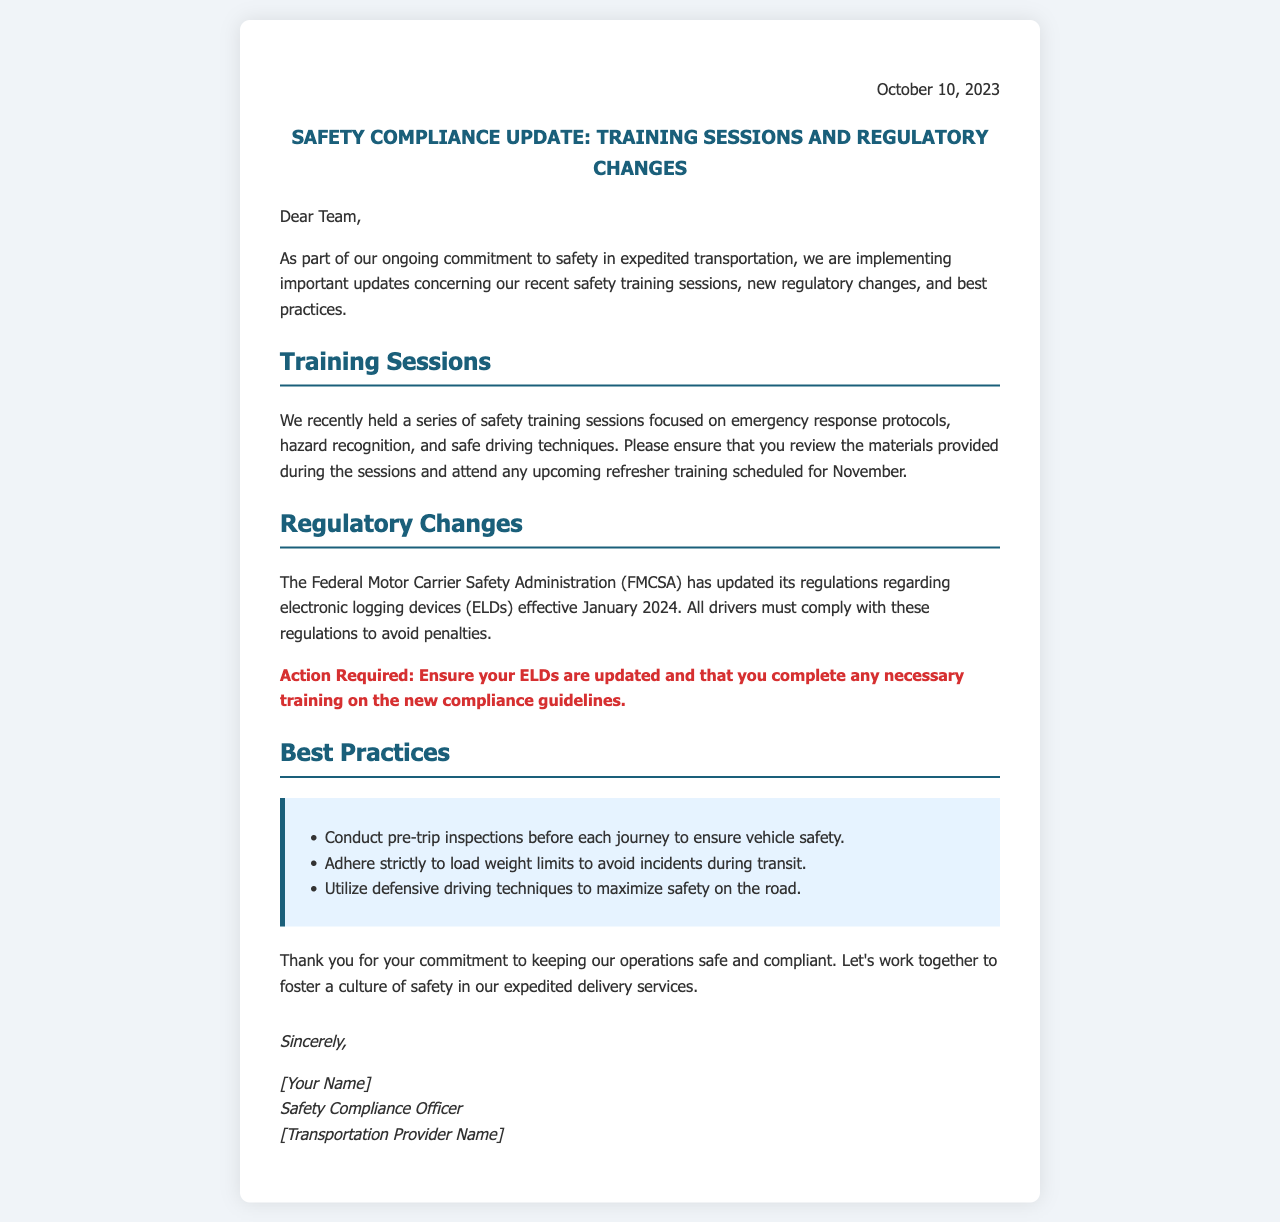What is the date of the letter? The date of the letter is mentioned at the start, indicating when it was written.
Answer: October 10, 2023 What is the main subject of the letter? The subject line provides a clear indication of what the letter generally addresses.
Answer: Safety Compliance Update: Training Sessions and Regulatory Changes What organization has updated its regulations? The document refers to the regulatory body responsible for the new rules concerning transport safety.
Answer: Federal Motor Carrier Safety Administration (FMCSA) When will drivers need to comply with the new electronic logging device regulations? The letter states when the new regulations will take effect, which is important for compliance planning.
Answer: January 2024 What is required of drivers regarding ELDs? Action required from the drivers is specified in a separate section of the letter.
Answer: Ensure your ELDs are updated What is one of the topics covered in the recent safety training sessions? The letter lists several topics that were included in the recent training sessions.
Answer: Emergency response protocols What best practice involves vehicle safety? The document includes a list of recommended practices to ensure safety during transport.
Answer: Conduct pre-trip inspections What is the tone of the letter towards staff compliance? Understanding the tone helps in evaluating the communication style used in the letter.
Answer: Commitment Who signed the letter? The signature section identifies the person who signed off on the letter, confirming authorship and responsibility.
Answer: [Your Name] 